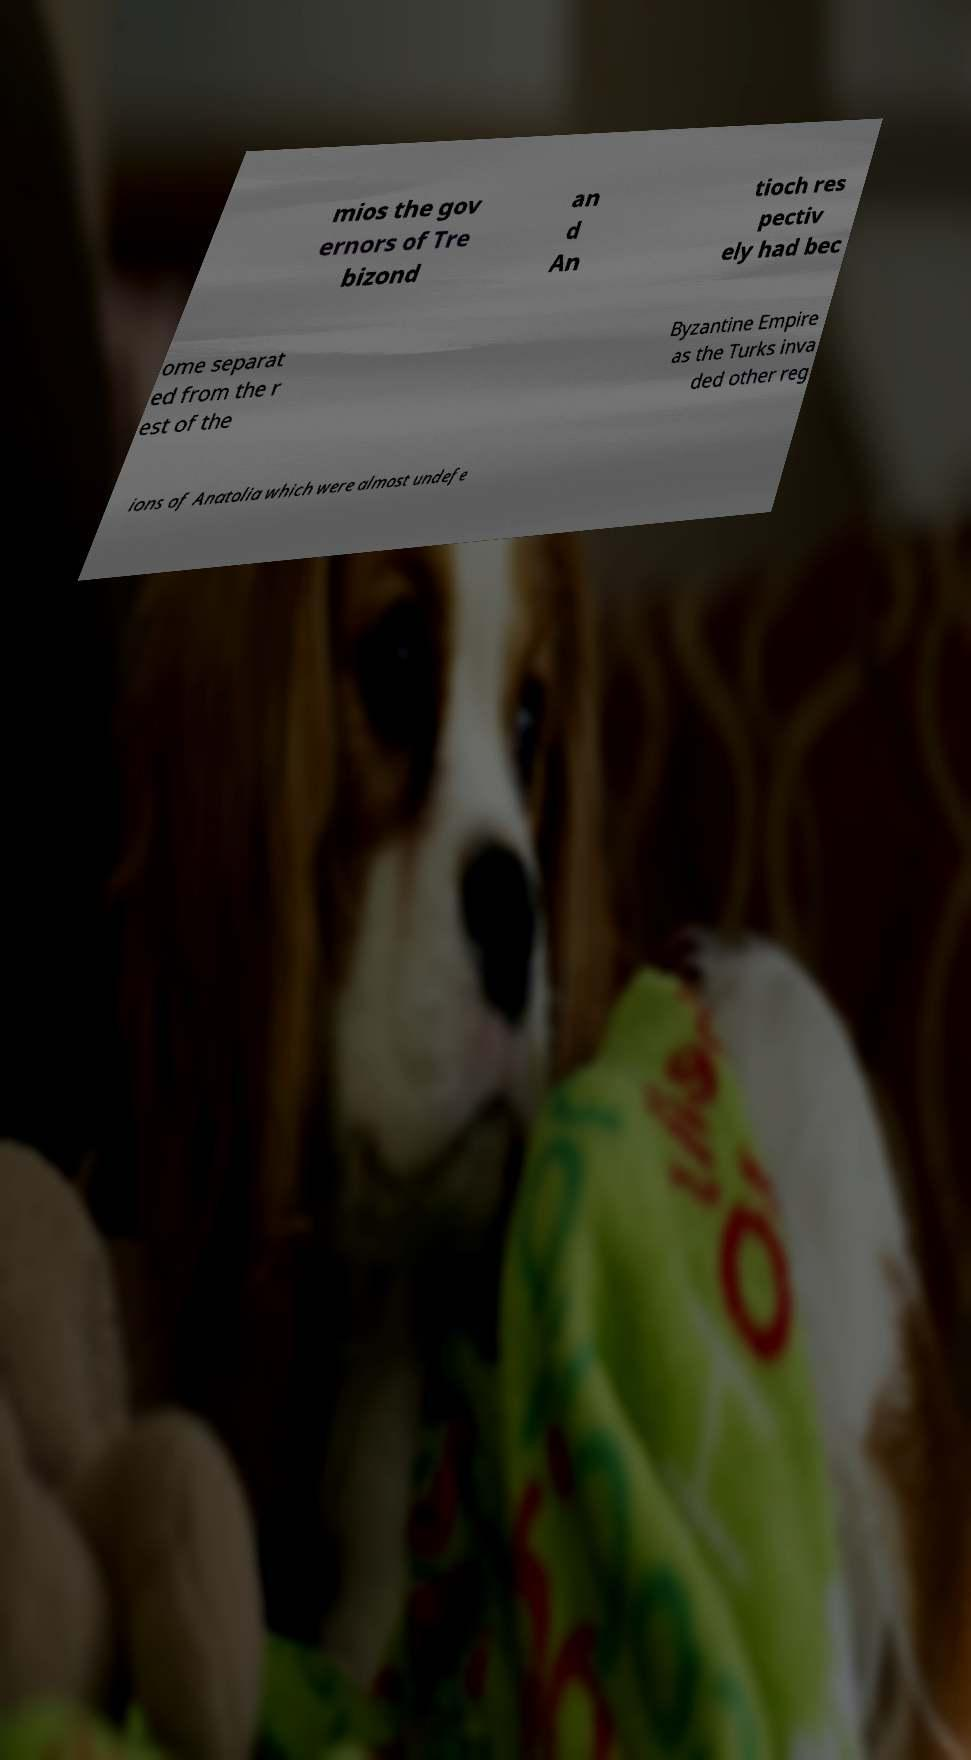Can you read and provide the text displayed in the image?This photo seems to have some interesting text. Can you extract and type it out for me? mios the gov ernors of Tre bizond an d An tioch res pectiv ely had bec ome separat ed from the r est of the Byzantine Empire as the Turks inva ded other reg ions of Anatolia which were almost undefe 